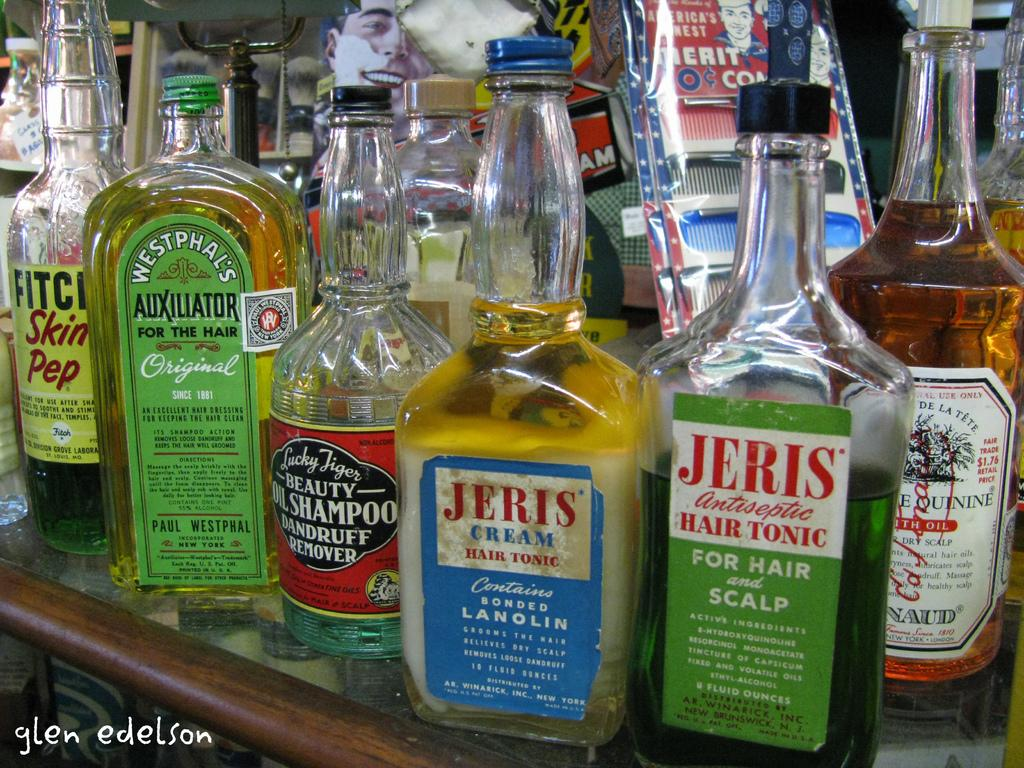<image>
Render a clear and concise summary of the photo. A bottle of Jeris Creams Hair Tonic that has a blue label. 